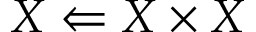Convert formula to latex. <formula><loc_0><loc_0><loc_500><loc_500>X \Leftarrow X \times X</formula> 